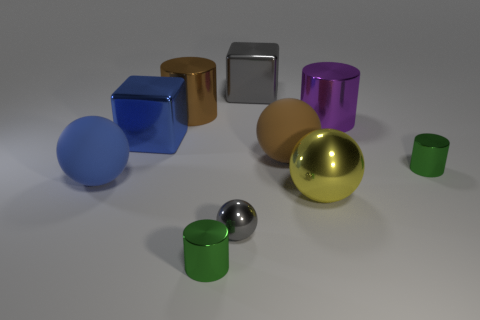Is the material of the gray object in front of the blue cube the same as the gray cube? Based on the appearance in the image, the material of the gray object in front of the blue cube seems to be quite similar to that of the gray cube. Both exhibit a matte finish and do not reflect light as strongly as the metallic spheres, suggesting that the two objects may indeed be made from the same or similar type of material. 